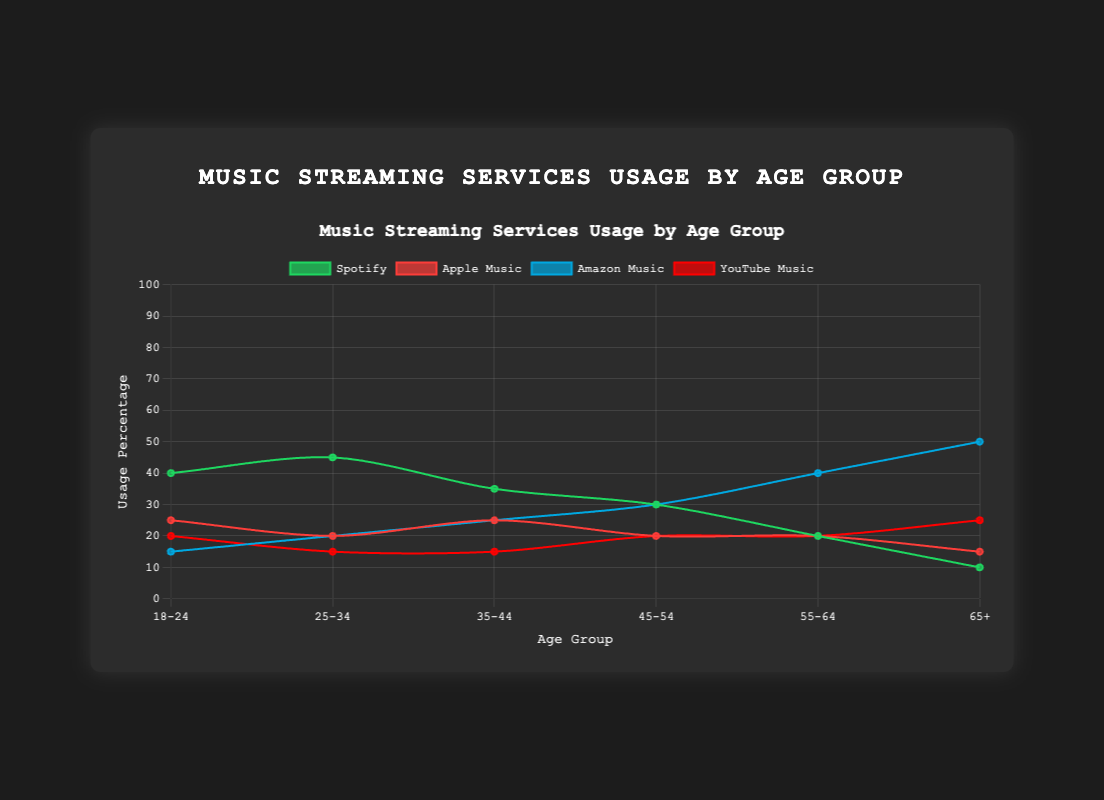What is the title of the chart? The title of the chart is usually displayed at the top of the figure and in this case, it is "Music Streaming Services Usage by Age Group".
Answer: Music Streaming Services Usage by Age Group Which music streaming service is most popular among the 25-34 age group? Looking at the area chart, the dataset for Spotify in the 25-34 age group has the highest percentage value.
Answer: Spotify What is the usage percentage of Apple Music for the 65+ age group? By observing the data points of the chart, Apple Music has a value of 15% for the 65+ age group.
Answer: 15% Which age group has the highest usage percentage for Amazon Music? The highest point in the area for Amazon Music is at 50% for the 65+ age group.
Answer: 65+ Compare the usage percentages of YouTube Music between the 18-24 and 35-44 age groups. Which age group uses it more? For YouTube Music, the 18-24 age group has a usage of 20% while the 35-44 age group has 15%. So, the 18-24 age group has a higher usage.
Answer: 18-24 What is the combined usage percentage of Apple Music for age groups 18-24 and 25-34? The usage of Apple Music is 25% for the 18-24 age group and 20% for 25-34. Adding these, 25 + 20 = 45%.
Answer: 45% Among the following age groups, which one has the lowest Spotify usage: 35-44, 45-54, or 55-64? By comparing the Spotify usage percentages: 35% for 35-44, 30% for 45-54, and 20% for 55-64. The 55-64 group has the lowest usage.
Answer: 55-64 What is the trend in Amazon Music usage as age increases? Observing the chart, Amazon Music shows an increasing trend with age, from 15% in the 18-24 age group to 50% in the 65+ age group.
Answer: Increasing What is the total usage percentage of all streaming services combined for the 45-54 age group? Summing the values for Spotify (30%), Apple Music (20%), Amazon Music (30%), and YouTube Music (20%) gives 30 + 20 + 30 + 20 = 100%.
Answer: 100% Compare the usage of Apple Music and Spotify in the 35-44 age group. Is the usage of Apple Music more than half of Spotify's usage? In the 35-44 age group, Spotify is at 35% and Apple Music at 25%. Half of Spotify's usage is 35 / 2 = 17.5%. Apple Music's usage (25%) is more than half of Spotify's usage.
Answer: Yes 